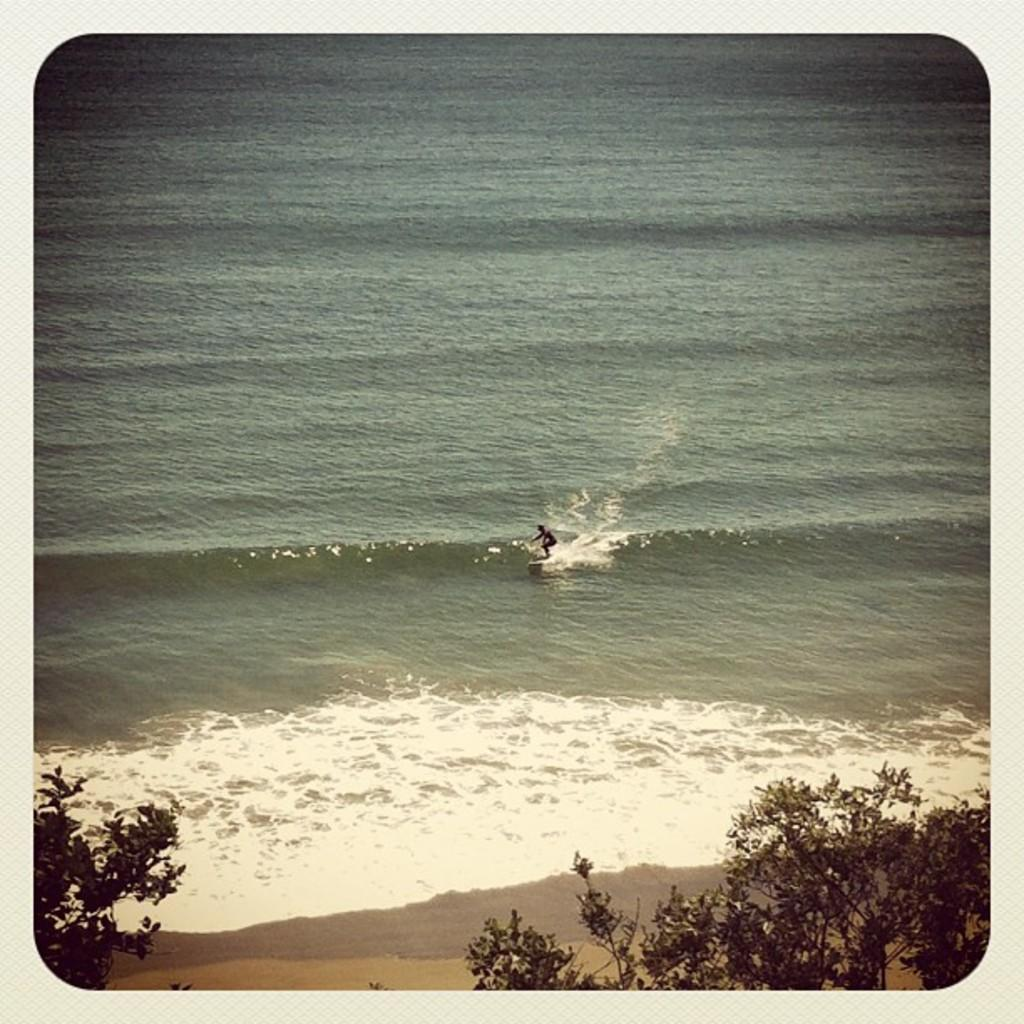Who is the main subject in the image? There is a person in the image. What is the person doing in the image? The person is standing on a surfing board. Where is the surfing board located? The surfing board is on a river. What can be seen in the background of the image? There are trees at the bottom of the image. Can you tell me how many chess pieces are on the river in the image? There are no chess pieces present in the image; it features a person standing on a surfing board on a river. What is the person's daughter doing in the image? There is no mention of a daughter in the image, only a person standing on a surfing board. 